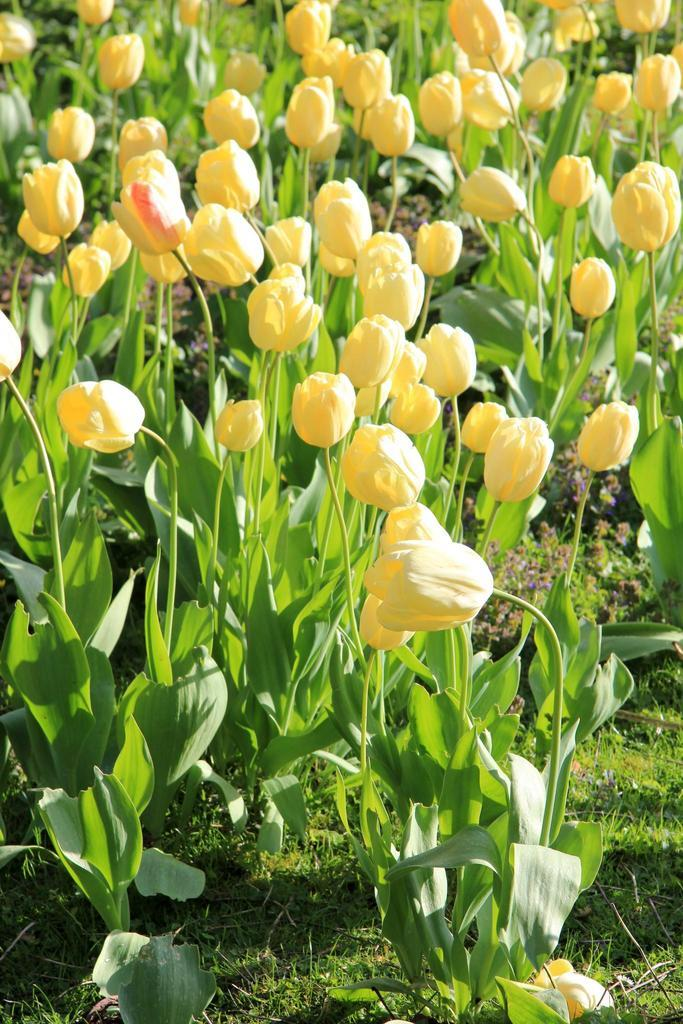What color are the flowers on the plants in the image? The flowers on the plants in the image are yellow. What type of vegetation covers the ground in the image? The ground is covered with grass in the image. What degree does the ant have in the image? There is no ant present in the image, so it cannot have a degree. 